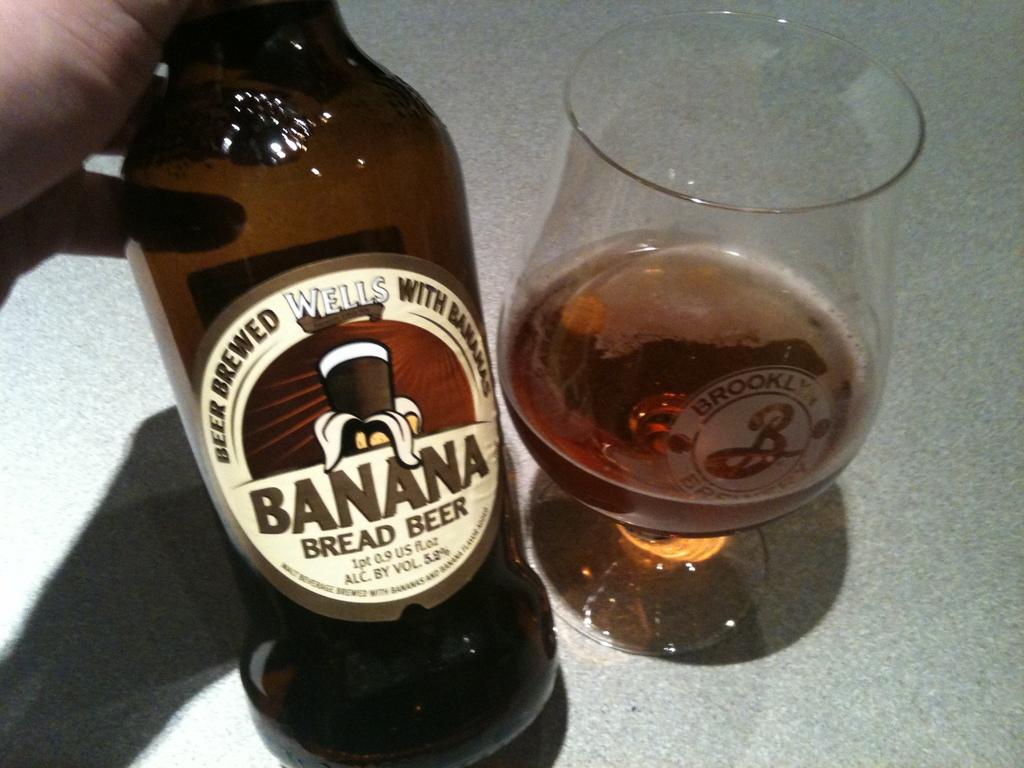How many fluid ounces are in this bottle?
Make the answer very short. 0.9. 